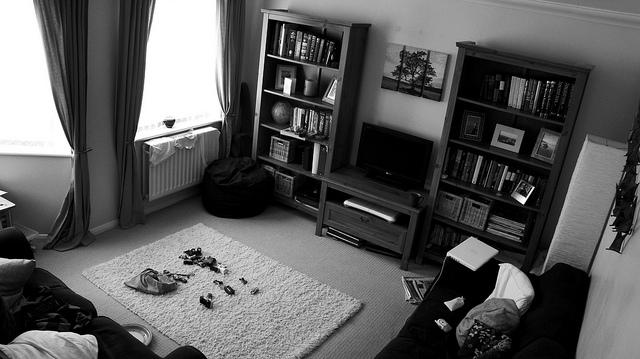Is there a mess on the rug?
Be succinct. Yes. Is there anything on the rug?
Quick response, please. Yes. IS this in color?
Keep it brief. No. 